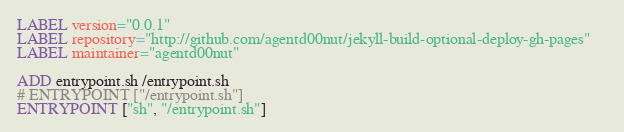Convert code to text. <code><loc_0><loc_0><loc_500><loc_500><_Dockerfile_>
LABEL version="0.0.1"
LABEL repository="http://github.com/agentd00nut/jekyll-build-optional-deploy-gh-pages"	
LABEL maintainer="agentd00nut"

ADD entrypoint.sh /entrypoint.sh
# ENTRYPOINT ["/entrypoint.sh"]
ENTRYPOINT ["sh", "/entrypoint.sh"]
</code> 